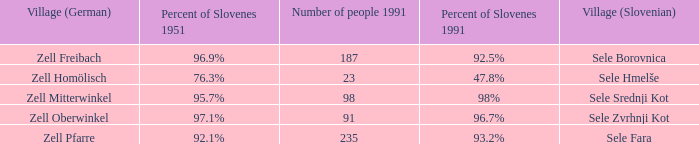Provide me with the names of all the villages (German) that has 76.3% of Slovenes in 1951. Zell Homölisch. 